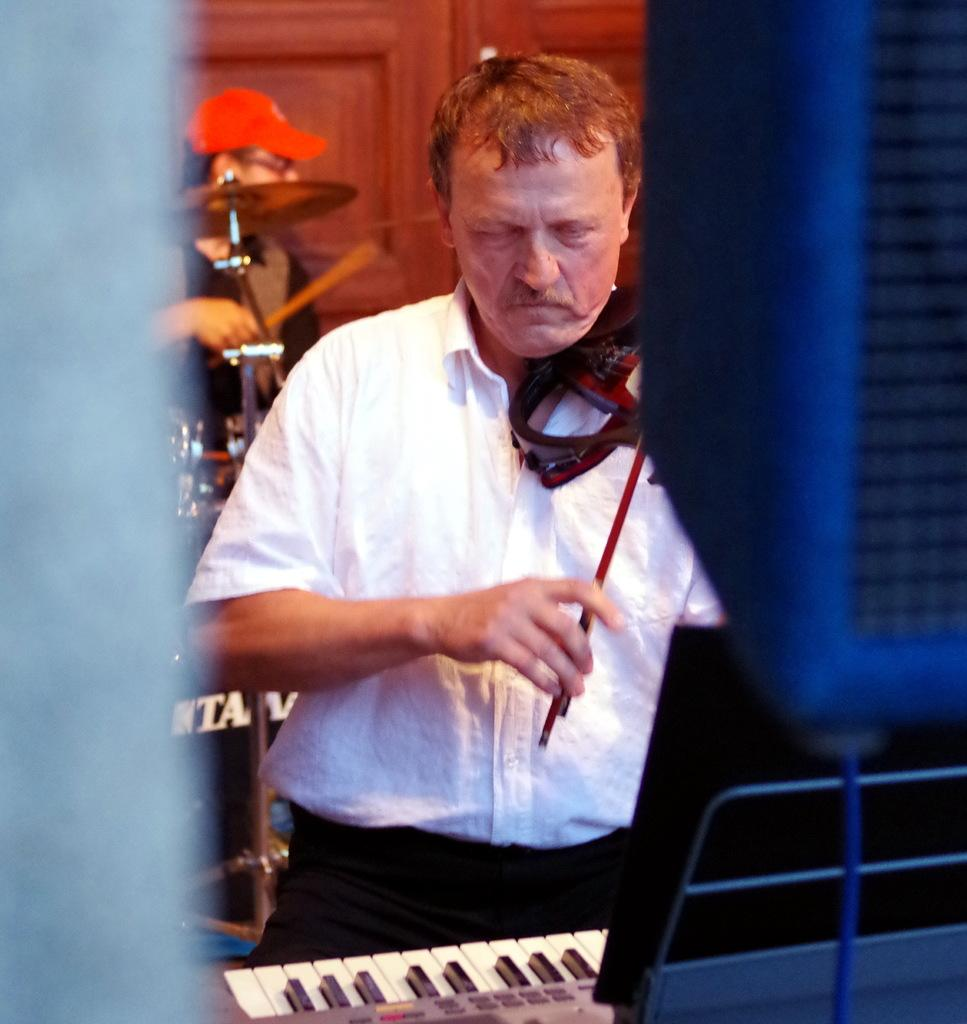What is the main activity taking place in the image? There are two people playing musical instruments in the image. Can you describe the instruments being played? One person is playing the violin, and another person is playing drums. What other musical instrument can be seen in the image? There is a piano in the image. What type of honey is being used to play the piano in the image? There is no honey present in the image, and the piano is not being played with honey. 